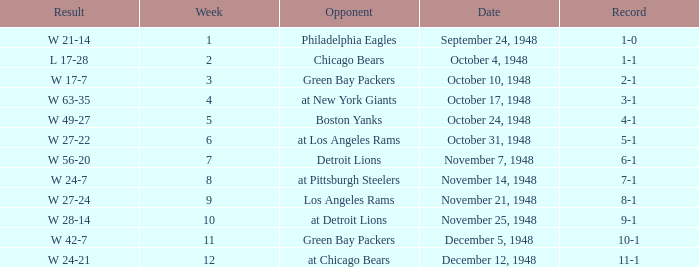What date was the opponent the Boston Yanks? October 24, 1948. 